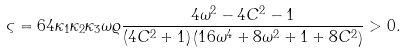Convert formula to latex. <formula><loc_0><loc_0><loc_500><loc_500>\varsigma = 6 4 \kappa _ { 1 } \kappa _ { 2 } \kappa _ { 3 } \omega \varrho \frac { 4 \omega ^ { 2 } - 4 C ^ { 2 } - 1 } { ( 4 C ^ { 2 } + 1 ) \left ( 1 6 \omega ^ { 4 } + 8 \omega ^ { 2 } + 1 + 8 C ^ { 2 } \right ) } > 0 .</formula> 